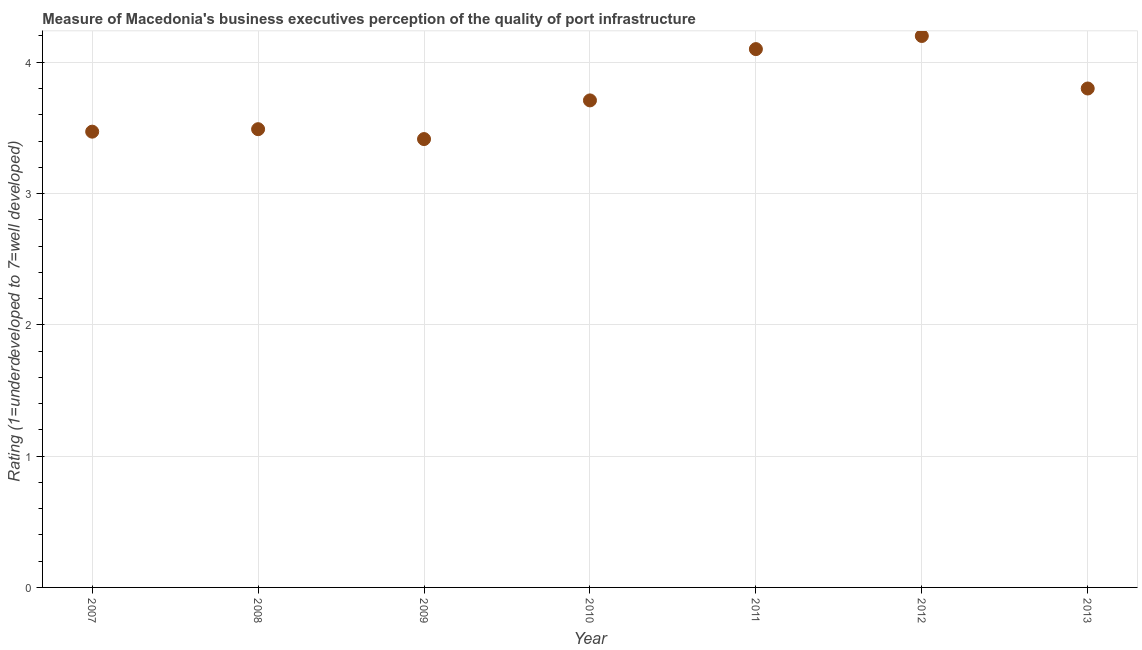What is the rating measuring quality of port infrastructure in 2008?
Provide a short and direct response. 3.49. Across all years, what is the minimum rating measuring quality of port infrastructure?
Provide a short and direct response. 3.41. In which year was the rating measuring quality of port infrastructure maximum?
Offer a terse response. 2012. In which year was the rating measuring quality of port infrastructure minimum?
Your answer should be very brief. 2009. What is the sum of the rating measuring quality of port infrastructure?
Your answer should be very brief. 26.19. What is the difference between the rating measuring quality of port infrastructure in 2011 and 2012?
Offer a very short reply. -0.1. What is the average rating measuring quality of port infrastructure per year?
Offer a very short reply. 3.74. What is the median rating measuring quality of port infrastructure?
Your answer should be very brief. 3.71. Do a majority of the years between 2010 and 2007 (inclusive) have rating measuring quality of port infrastructure greater than 0.4 ?
Your answer should be compact. Yes. What is the ratio of the rating measuring quality of port infrastructure in 2009 to that in 2012?
Offer a very short reply. 0.81. Is the difference between the rating measuring quality of port infrastructure in 2008 and 2010 greater than the difference between any two years?
Offer a terse response. No. What is the difference between the highest and the second highest rating measuring quality of port infrastructure?
Your answer should be very brief. 0.1. What is the difference between the highest and the lowest rating measuring quality of port infrastructure?
Provide a succinct answer. 0.79. In how many years, is the rating measuring quality of port infrastructure greater than the average rating measuring quality of port infrastructure taken over all years?
Give a very brief answer. 3. Does the rating measuring quality of port infrastructure monotonically increase over the years?
Give a very brief answer. No. How many dotlines are there?
Your response must be concise. 1. What is the title of the graph?
Your answer should be compact. Measure of Macedonia's business executives perception of the quality of port infrastructure. What is the label or title of the X-axis?
Offer a very short reply. Year. What is the label or title of the Y-axis?
Your response must be concise. Rating (1=underdeveloped to 7=well developed) . What is the Rating (1=underdeveloped to 7=well developed)  in 2007?
Give a very brief answer. 3.47. What is the Rating (1=underdeveloped to 7=well developed)  in 2008?
Offer a terse response. 3.49. What is the Rating (1=underdeveloped to 7=well developed)  in 2009?
Your answer should be very brief. 3.41. What is the Rating (1=underdeveloped to 7=well developed)  in 2010?
Offer a very short reply. 3.71. What is the Rating (1=underdeveloped to 7=well developed)  in 2011?
Offer a very short reply. 4.1. What is the Rating (1=underdeveloped to 7=well developed)  in 2013?
Provide a succinct answer. 3.8. What is the difference between the Rating (1=underdeveloped to 7=well developed)  in 2007 and 2008?
Ensure brevity in your answer.  -0.02. What is the difference between the Rating (1=underdeveloped to 7=well developed)  in 2007 and 2009?
Give a very brief answer. 0.06. What is the difference between the Rating (1=underdeveloped to 7=well developed)  in 2007 and 2010?
Provide a succinct answer. -0.24. What is the difference between the Rating (1=underdeveloped to 7=well developed)  in 2007 and 2011?
Provide a succinct answer. -0.63. What is the difference between the Rating (1=underdeveloped to 7=well developed)  in 2007 and 2012?
Make the answer very short. -0.73. What is the difference between the Rating (1=underdeveloped to 7=well developed)  in 2007 and 2013?
Give a very brief answer. -0.33. What is the difference between the Rating (1=underdeveloped to 7=well developed)  in 2008 and 2009?
Your response must be concise. 0.08. What is the difference between the Rating (1=underdeveloped to 7=well developed)  in 2008 and 2010?
Your answer should be very brief. -0.22. What is the difference between the Rating (1=underdeveloped to 7=well developed)  in 2008 and 2011?
Your answer should be very brief. -0.61. What is the difference between the Rating (1=underdeveloped to 7=well developed)  in 2008 and 2012?
Give a very brief answer. -0.71. What is the difference between the Rating (1=underdeveloped to 7=well developed)  in 2008 and 2013?
Your response must be concise. -0.31. What is the difference between the Rating (1=underdeveloped to 7=well developed)  in 2009 and 2010?
Your answer should be very brief. -0.29. What is the difference between the Rating (1=underdeveloped to 7=well developed)  in 2009 and 2011?
Provide a succinct answer. -0.69. What is the difference between the Rating (1=underdeveloped to 7=well developed)  in 2009 and 2012?
Your response must be concise. -0.79. What is the difference between the Rating (1=underdeveloped to 7=well developed)  in 2009 and 2013?
Offer a terse response. -0.39. What is the difference between the Rating (1=underdeveloped to 7=well developed)  in 2010 and 2011?
Provide a short and direct response. -0.39. What is the difference between the Rating (1=underdeveloped to 7=well developed)  in 2010 and 2012?
Provide a short and direct response. -0.49. What is the difference between the Rating (1=underdeveloped to 7=well developed)  in 2010 and 2013?
Make the answer very short. -0.09. What is the difference between the Rating (1=underdeveloped to 7=well developed)  in 2011 and 2012?
Provide a succinct answer. -0.1. What is the difference between the Rating (1=underdeveloped to 7=well developed)  in 2012 and 2013?
Give a very brief answer. 0.4. What is the ratio of the Rating (1=underdeveloped to 7=well developed)  in 2007 to that in 2008?
Provide a short and direct response. 0.99. What is the ratio of the Rating (1=underdeveloped to 7=well developed)  in 2007 to that in 2009?
Ensure brevity in your answer.  1.02. What is the ratio of the Rating (1=underdeveloped to 7=well developed)  in 2007 to that in 2010?
Ensure brevity in your answer.  0.94. What is the ratio of the Rating (1=underdeveloped to 7=well developed)  in 2007 to that in 2011?
Offer a terse response. 0.85. What is the ratio of the Rating (1=underdeveloped to 7=well developed)  in 2007 to that in 2012?
Ensure brevity in your answer.  0.83. What is the ratio of the Rating (1=underdeveloped to 7=well developed)  in 2007 to that in 2013?
Your response must be concise. 0.91. What is the ratio of the Rating (1=underdeveloped to 7=well developed)  in 2008 to that in 2009?
Offer a very short reply. 1.02. What is the ratio of the Rating (1=underdeveloped to 7=well developed)  in 2008 to that in 2010?
Make the answer very short. 0.94. What is the ratio of the Rating (1=underdeveloped to 7=well developed)  in 2008 to that in 2011?
Keep it short and to the point. 0.85. What is the ratio of the Rating (1=underdeveloped to 7=well developed)  in 2008 to that in 2012?
Ensure brevity in your answer.  0.83. What is the ratio of the Rating (1=underdeveloped to 7=well developed)  in 2008 to that in 2013?
Offer a very short reply. 0.92. What is the ratio of the Rating (1=underdeveloped to 7=well developed)  in 2009 to that in 2010?
Your answer should be very brief. 0.92. What is the ratio of the Rating (1=underdeveloped to 7=well developed)  in 2009 to that in 2011?
Offer a very short reply. 0.83. What is the ratio of the Rating (1=underdeveloped to 7=well developed)  in 2009 to that in 2012?
Your response must be concise. 0.81. What is the ratio of the Rating (1=underdeveloped to 7=well developed)  in 2009 to that in 2013?
Offer a very short reply. 0.9. What is the ratio of the Rating (1=underdeveloped to 7=well developed)  in 2010 to that in 2011?
Your answer should be compact. 0.91. What is the ratio of the Rating (1=underdeveloped to 7=well developed)  in 2010 to that in 2012?
Ensure brevity in your answer.  0.88. What is the ratio of the Rating (1=underdeveloped to 7=well developed)  in 2011 to that in 2013?
Give a very brief answer. 1.08. What is the ratio of the Rating (1=underdeveloped to 7=well developed)  in 2012 to that in 2013?
Offer a terse response. 1.1. 